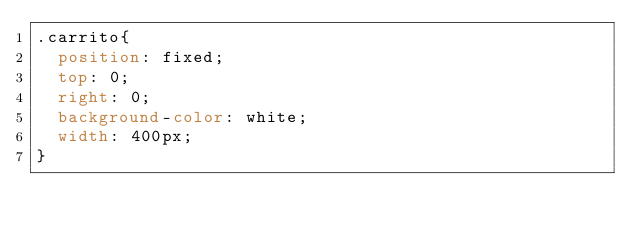<code> <loc_0><loc_0><loc_500><loc_500><_CSS_>.carrito{
  position: fixed;
  top: 0;
  right: 0;
  background-color: white;
  width: 400px;
}</code> 